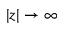Convert formula to latex. <formula><loc_0><loc_0><loc_500><loc_500>| z | \rightarrow \infty</formula> 